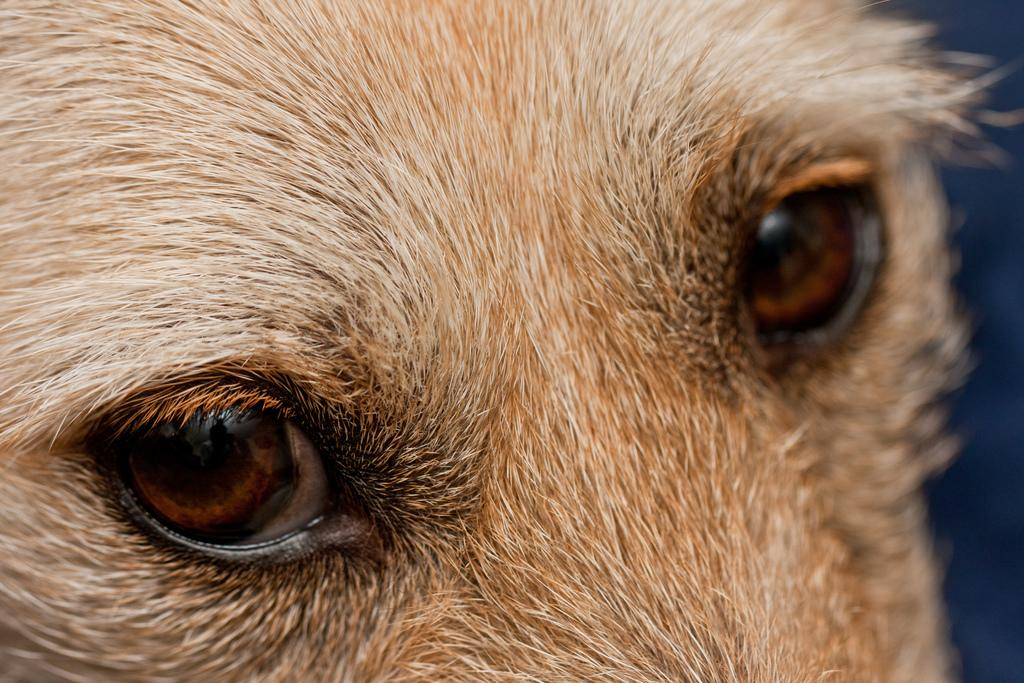What type of animal is in the image? There is a brown color dog in the image. What is the dog doing in the image? The dog is looking into the camera. What type of milk is the dog drinking in the image? There is no milk present in the image, and the dog is not drinking anything. 